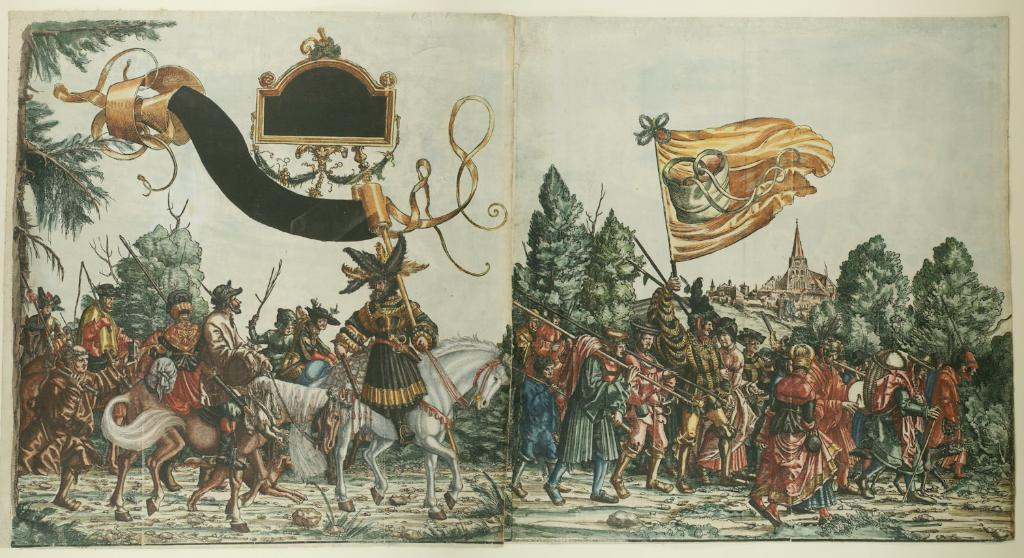What type of artwork is depicted in the image? The image is a painting. What subjects are present in the painting? There are persons and horses in the painting. What other elements can be seen in the painting? There are stones, trees, a flag, a fort, a hill, and the sky visible in the painting. What type of instrument is being played by the man in the painting? There is no man present in the painting, and therefore no instrument being played. 